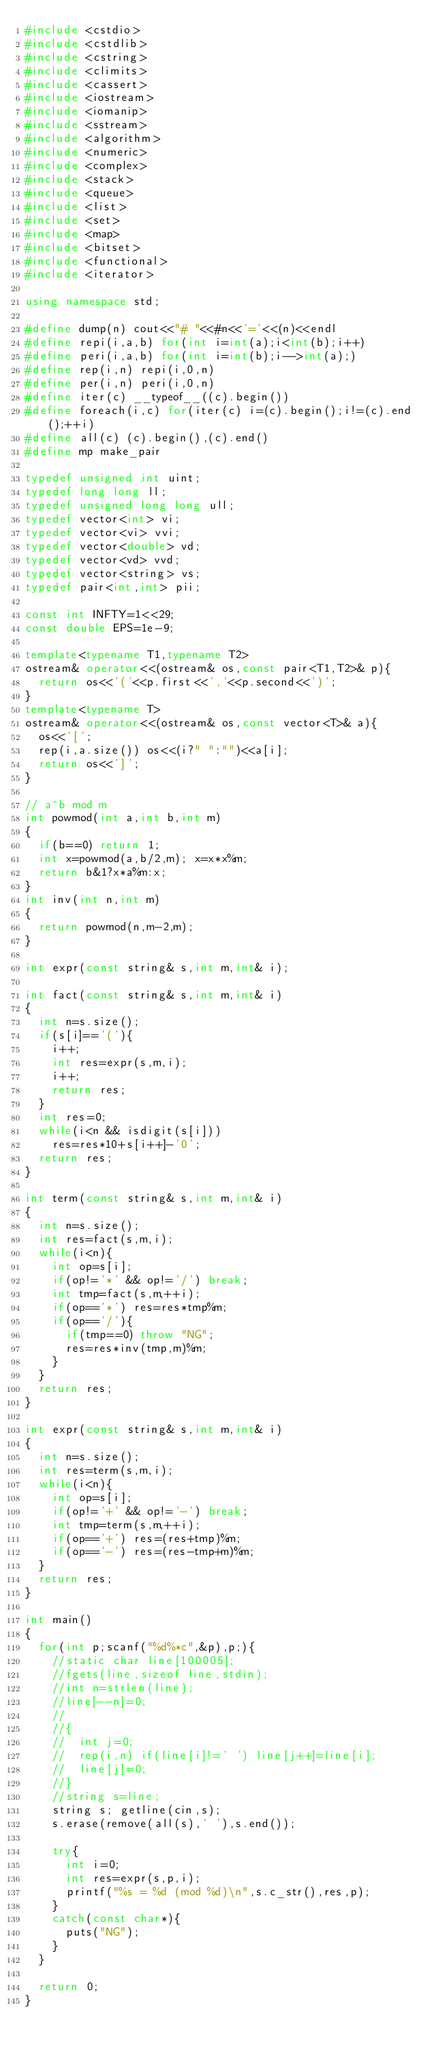Convert code to text. <code><loc_0><loc_0><loc_500><loc_500><_C++_>#include <cstdio>
#include <cstdlib>
#include <cstring>
#include <climits>
#include <cassert>
#include <iostream>
#include <iomanip>
#include <sstream>
#include <algorithm>
#include <numeric>
#include <complex>
#include <stack>
#include <queue>
#include <list>
#include <set>
#include <map>
#include <bitset>
#include <functional>
#include <iterator>

using namespace std;

#define dump(n) cout<<"# "<<#n<<'='<<(n)<<endl
#define repi(i,a,b) for(int i=int(a);i<int(b);i++)
#define peri(i,a,b) for(int i=int(b);i-->int(a);)
#define rep(i,n) repi(i,0,n)
#define per(i,n) peri(i,0,n)
#define iter(c) __typeof__((c).begin())
#define foreach(i,c) for(iter(c) i=(c).begin();i!=(c).end();++i)
#define all(c) (c).begin(),(c).end()
#define mp make_pair

typedef unsigned int uint;
typedef long long ll;
typedef unsigned long long ull;
typedef vector<int> vi;
typedef vector<vi> vvi;
typedef vector<double> vd;
typedef vector<vd> vvd;
typedef vector<string> vs;
typedef pair<int,int> pii;

const int INFTY=1<<29;
const double EPS=1e-9;

template<typename T1,typename T2>
ostream& operator<<(ostream& os,const pair<T1,T2>& p){
	return os<<'('<<p.first<<','<<p.second<<')';
}
template<typename T>
ostream& operator<<(ostream& os,const vector<T>& a){
	os<<'[';
	rep(i,a.size()) os<<(i?" ":"")<<a[i];
	return os<<']';
}

// a^b mod m
int powmod(int a,int b,int m)
{
	if(b==0) return 1;
	int x=powmod(a,b/2,m); x=x*x%m;
	return b&1?x*a%m:x;
}
int inv(int n,int m)
{
	return powmod(n,m-2,m);
}

int expr(const string& s,int m,int& i);

int fact(const string& s,int m,int& i)
{
	int n=s.size();
	if(s[i]=='('){
		i++;
		int res=expr(s,m,i);
		i++;
		return res;
	}
	int res=0;
	while(i<n && isdigit(s[i]))
		res=res*10+s[i++]-'0';
	return res;
}

int term(const string& s,int m,int& i)
{
	int n=s.size();
	int res=fact(s,m,i);
	while(i<n){
		int op=s[i];
		if(op!='*' && op!='/') break;
		int tmp=fact(s,m,++i);
		if(op=='*') res=res*tmp%m;
		if(op=='/'){
			if(tmp==0) throw "NG";
			res=res*inv(tmp,m)%m;
		}
	}
	return res;
}

int expr(const string& s,int m,int& i)
{
	int n=s.size();
	int res=term(s,m,i);
	while(i<n){
		int op=s[i];
		if(op!='+' && op!='-') break;
		int tmp=term(s,m,++i);
		if(op=='+') res=(res+tmp)%m;
		if(op=='-') res=(res-tmp+m)%m;
	}
	return res;
}

int main()
{
	for(int p;scanf("%d%*c",&p),p;){
		//static char line[100005]; 
		//fgets(line,sizeof line,stdin);
		//int n=strlen(line); 
		//line[--n]=0;
		//
		//{
		//	int j=0;
		//	rep(i,n) if(line[i]!=' ') line[j++]=line[i];
		//	line[j]=0;
		//}
		//string s=line;
		string s; getline(cin,s);
		s.erase(remove(all(s),' '),s.end());
		
		try{
			int i=0;
			int res=expr(s,p,i);
			printf("%s = %d (mod %d)\n",s.c_str(),res,p);
		}
		catch(const char*){
			puts("NG");
		}
	}
	
	return 0;
}</code> 